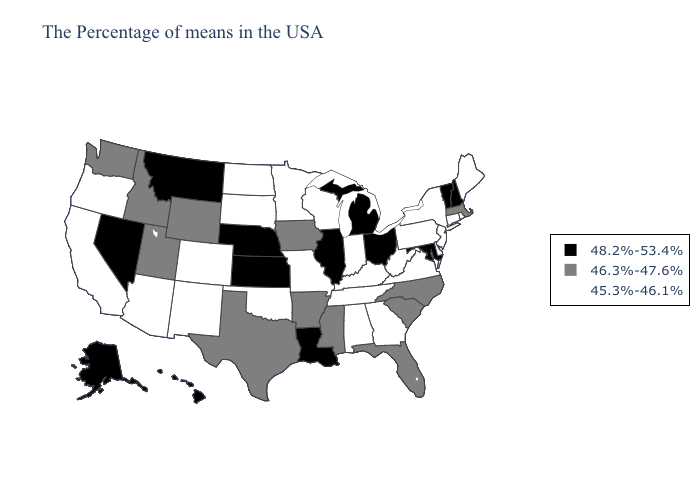What is the value of Florida?
Give a very brief answer. 46.3%-47.6%. Which states hav the highest value in the Northeast?
Answer briefly. New Hampshire, Vermont. Name the states that have a value in the range 46.3%-47.6%?
Be succinct. Massachusetts, North Carolina, South Carolina, Florida, Mississippi, Arkansas, Iowa, Texas, Wyoming, Utah, Idaho, Washington. Does Minnesota have a lower value than South Dakota?
Concise answer only. No. Name the states that have a value in the range 45.3%-46.1%?
Concise answer only. Maine, Rhode Island, Connecticut, New York, New Jersey, Delaware, Pennsylvania, Virginia, West Virginia, Georgia, Kentucky, Indiana, Alabama, Tennessee, Wisconsin, Missouri, Minnesota, Oklahoma, South Dakota, North Dakota, Colorado, New Mexico, Arizona, California, Oregon. What is the lowest value in states that border Georgia?
Short answer required. 45.3%-46.1%. Does New Jersey have the same value as Oregon?
Be succinct. Yes. Which states have the lowest value in the USA?
Give a very brief answer. Maine, Rhode Island, Connecticut, New York, New Jersey, Delaware, Pennsylvania, Virginia, West Virginia, Georgia, Kentucky, Indiana, Alabama, Tennessee, Wisconsin, Missouri, Minnesota, Oklahoma, South Dakota, North Dakota, Colorado, New Mexico, Arizona, California, Oregon. Among the states that border Florida , which have the highest value?
Give a very brief answer. Georgia, Alabama. Among the states that border Illinois , does Iowa have the highest value?
Answer briefly. Yes. Name the states that have a value in the range 45.3%-46.1%?
Concise answer only. Maine, Rhode Island, Connecticut, New York, New Jersey, Delaware, Pennsylvania, Virginia, West Virginia, Georgia, Kentucky, Indiana, Alabama, Tennessee, Wisconsin, Missouri, Minnesota, Oklahoma, South Dakota, North Dakota, Colorado, New Mexico, Arizona, California, Oregon. Name the states that have a value in the range 45.3%-46.1%?
Quick response, please. Maine, Rhode Island, Connecticut, New York, New Jersey, Delaware, Pennsylvania, Virginia, West Virginia, Georgia, Kentucky, Indiana, Alabama, Tennessee, Wisconsin, Missouri, Minnesota, Oklahoma, South Dakota, North Dakota, Colorado, New Mexico, Arizona, California, Oregon. What is the lowest value in the West?
Concise answer only. 45.3%-46.1%. Which states have the highest value in the USA?
Answer briefly. New Hampshire, Vermont, Maryland, Ohio, Michigan, Illinois, Louisiana, Kansas, Nebraska, Montana, Nevada, Alaska, Hawaii. Which states have the lowest value in the Northeast?
Give a very brief answer. Maine, Rhode Island, Connecticut, New York, New Jersey, Pennsylvania. 